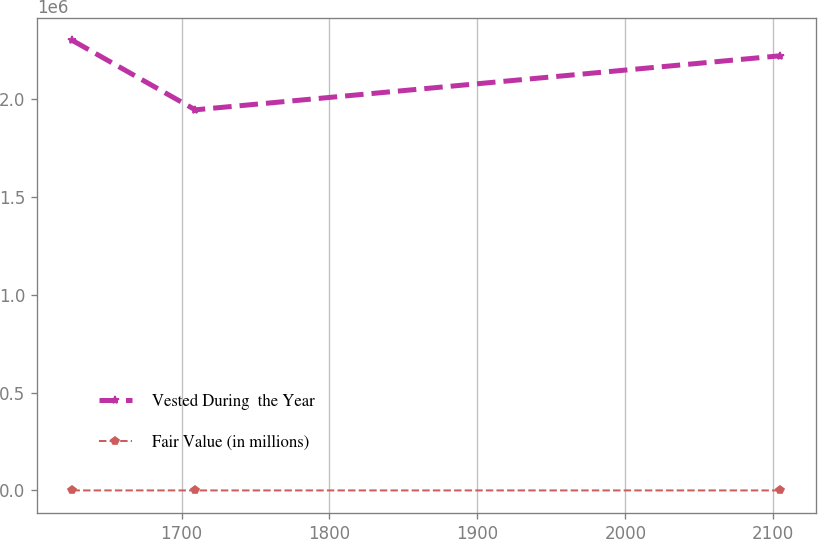<chart> <loc_0><loc_0><loc_500><loc_500><line_chart><ecel><fcel>Vested During  the Year<fcel>Fair Value (in millions)<nl><fcel>1626.25<fcel>2.29966e+06<fcel>76.46<nl><fcel>1709.25<fcel>1.9452e+06<fcel>63.77<nl><fcel>2104.71<fcel>2.22154e+06<fcel>55.09<nl></chart> 